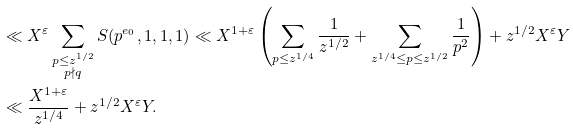Convert formula to latex. <formula><loc_0><loc_0><loc_500><loc_500>& \ll X ^ { \varepsilon } \sum _ { \substack { p \leq z ^ { 1 / 2 } \\ p \nmid q } } S ( p ^ { e _ { 0 } } , 1 , 1 , 1 ) \ll X ^ { 1 + \varepsilon } \left ( \sum _ { p \leq z ^ { 1 / 4 } } \frac { 1 } { z ^ { 1 / 2 } } + \sum _ { z ^ { 1 / 4 } \leq p \leq z ^ { 1 / 2 } } \frac { 1 } { p ^ { 2 } } \right ) + z ^ { 1 / 2 } X ^ { \varepsilon } Y \\ & \ll \frac { X ^ { 1 + \varepsilon } } { z ^ { 1 / 4 } } + z ^ { 1 / 2 } X ^ { \varepsilon } Y .</formula> 